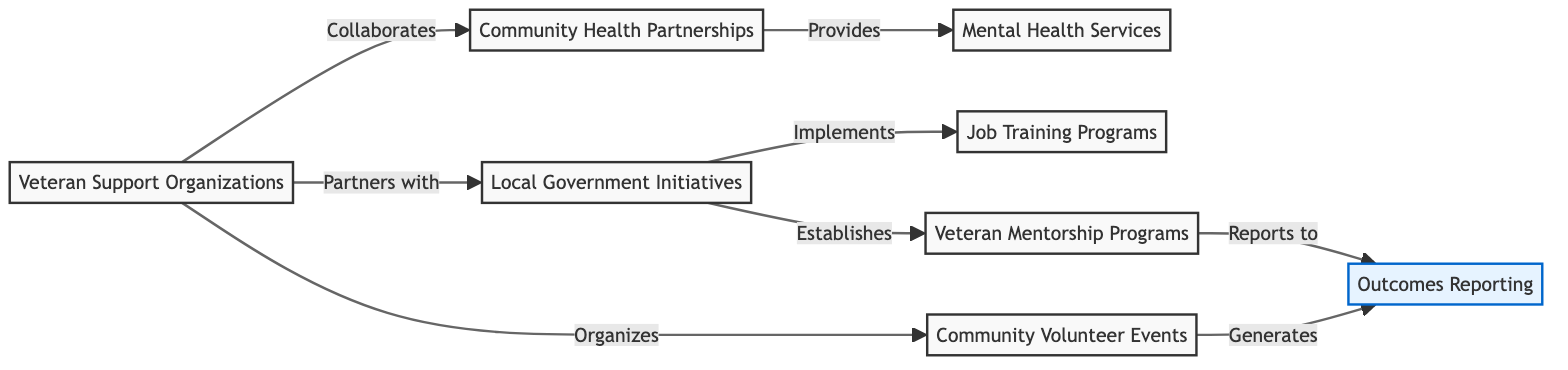What is the total number of nodes in the diagram? Counting the nodes listed, there are eight distinct entities: Veteran Support Organizations, Community Health Partnerships, Local Government Initiatives, Job Training Programs, Veteran Mentorship Programs, Mental Health Services, Community Volunteer Events, and Outcomes Reporting. Thus, the total number of nodes is 8.
Answer: 8 Which node collaborates with Community Health Partnerships? The diagram indicates that Veteran Support Organizations is connected with a collaboration line pointing to Community Health Partnerships, indicating this relationship.
Answer: Veteran Support Organizations What relationship exists between Local Government Initiatives and Job Training Programs? Examining the directed edges, Local Government Initiatives points to Job Training Programs, specified by the label "Implements". This indicates a functional relationship where initiatives lead to the job training program implementation.
Answer: Implements How many edges are in the diagram? The edges represent connections between nodes and there are a total of seven connections noted, illustrating how various entities interact or relate to one another.
Answer: 7 Which node generates Outcomes Reporting? The diagram shows that Community Volunteer Events directly points to Outcomes Reporting with a label stating "Generates", indicating it is responsible for this reporting activity.
Answer: Community Volunteer Events What type of relationship exists between Veteran Mentorship Programs and Outcomes Reporting? The edge from Veteran Mentorship Programs to Outcomes Reporting is labeled "Reports to", suggesting a reporting relationship such that data or results from mentorship are provided to the outcomes reporting node.
Answer: Reports to Which node has the most incoming relationships? Assessing the incoming edges, Outcomes Reporting has two edges directed towards it: one from Community Volunteer Events and one from Veteran Mentorship Programs. This is more than any other node, which typically has fewer or none directing towards them.
Answer: Outcomes Reporting What do Community Health Partnerships provide? The edge from Community Health Partnerships to Mental Health Services is marked "Provides", indicating that this partnership is a source or provider of mental health services in support of community engagement initiatives.
Answer: Provides Which node is directly connected to Job Training Programs? Job Training Programs is directly linked from Local Government Initiatives, illustrating a straightforward relationship where local initiatives are implemented to establish the training program.
Answer: Local Government Initiatives 